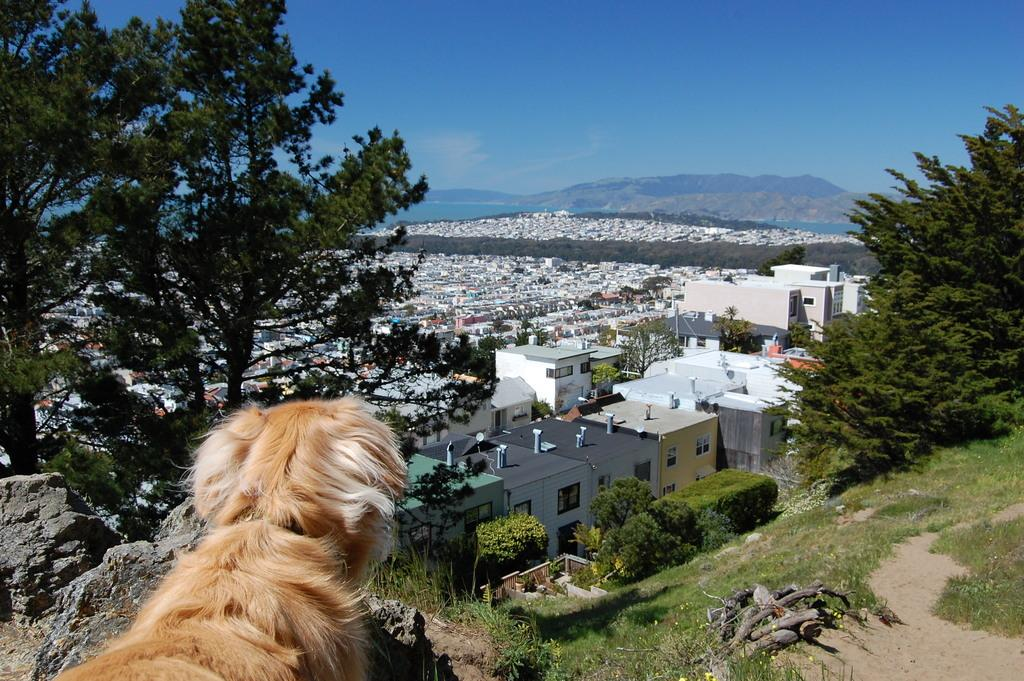What type of vegetation can be seen in the image? There are trees and grass in the image. What living creature is present in the image? There is a dog in the image. What type of structures can be seen in the image? There are buildings in the image. What other living organisms can be seen in the image? There are plants in the image. What is visible at the top of the image? The sky is visible at the top of the image. What is the purpose of the beds in the image? There are no beds present in the image. What type of picture is the dog holding in the image? There is no picture present in the image, and the dog is not holding anything. 